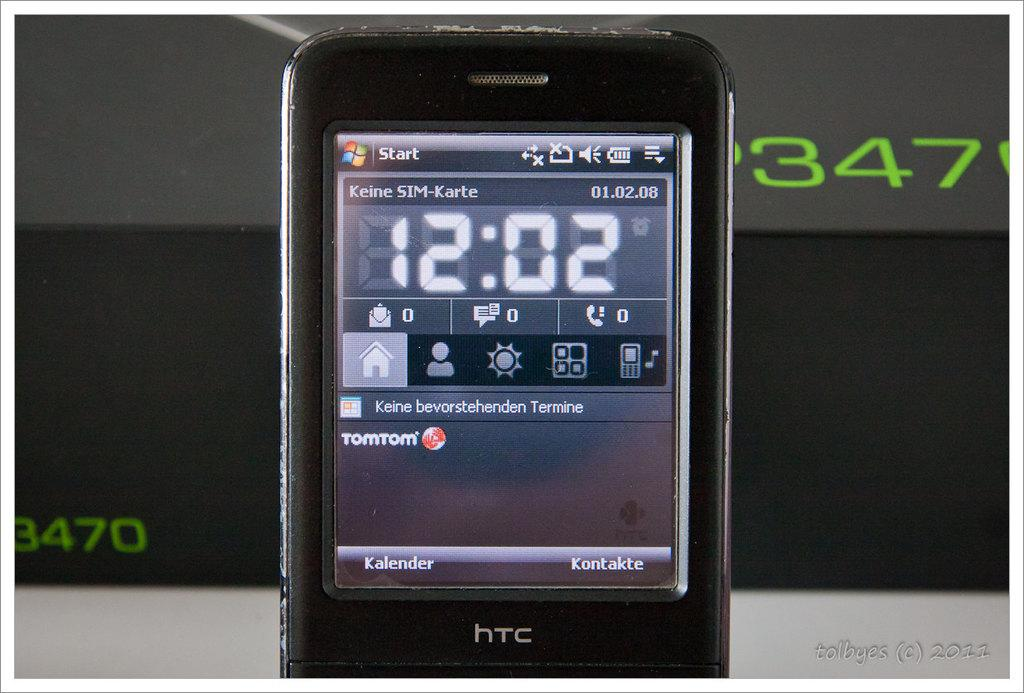Provide a one-sentence caption for the provided image. Old HTC cellphone with a start button on the top and the time showing 12:02. 